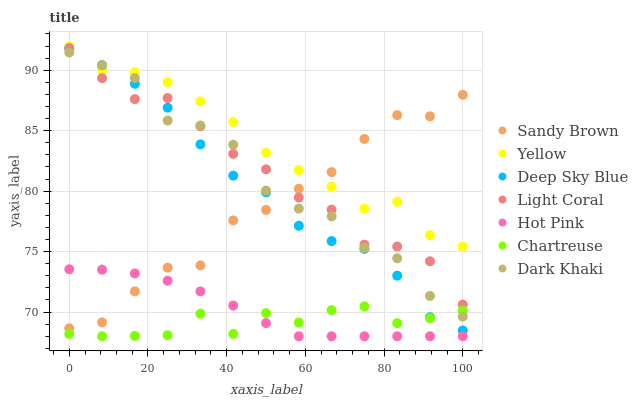Does Chartreuse have the minimum area under the curve?
Answer yes or no. Yes. Does Yellow have the maximum area under the curve?
Answer yes or no. Yes. Does Hot Pink have the minimum area under the curve?
Answer yes or no. No. Does Hot Pink have the maximum area under the curve?
Answer yes or no. No. Is Hot Pink the smoothest?
Answer yes or no. Yes. Is Dark Khaki the roughest?
Answer yes or no. Yes. Is Yellow the smoothest?
Answer yes or no. No. Is Yellow the roughest?
Answer yes or no. No. Does Hot Pink have the lowest value?
Answer yes or no. Yes. Does Yellow have the lowest value?
Answer yes or no. No. Does Yellow have the highest value?
Answer yes or no. Yes. Does Hot Pink have the highest value?
Answer yes or no. No. Is Chartreuse less than Yellow?
Answer yes or no. Yes. Is Yellow greater than Chartreuse?
Answer yes or no. Yes. Does Dark Khaki intersect Light Coral?
Answer yes or no. Yes. Is Dark Khaki less than Light Coral?
Answer yes or no. No. Is Dark Khaki greater than Light Coral?
Answer yes or no. No. Does Chartreuse intersect Yellow?
Answer yes or no. No. 